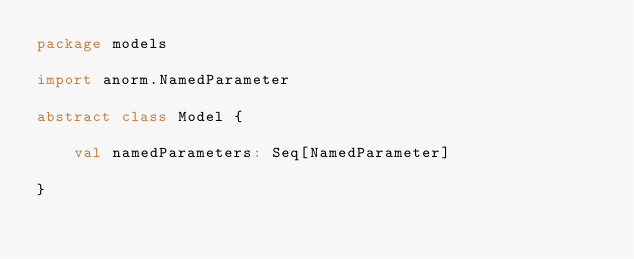<code> <loc_0><loc_0><loc_500><loc_500><_Scala_>package models

import anorm.NamedParameter

abstract class Model {

    val namedParameters: Seq[NamedParameter]

}
</code> 